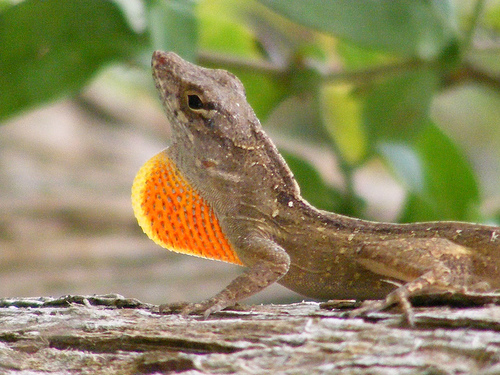<image>
Is there a lizard on the leaves? No. The lizard is not positioned on the leaves. They may be near each other, but the lizard is not supported by or resting on top of the leaves. 